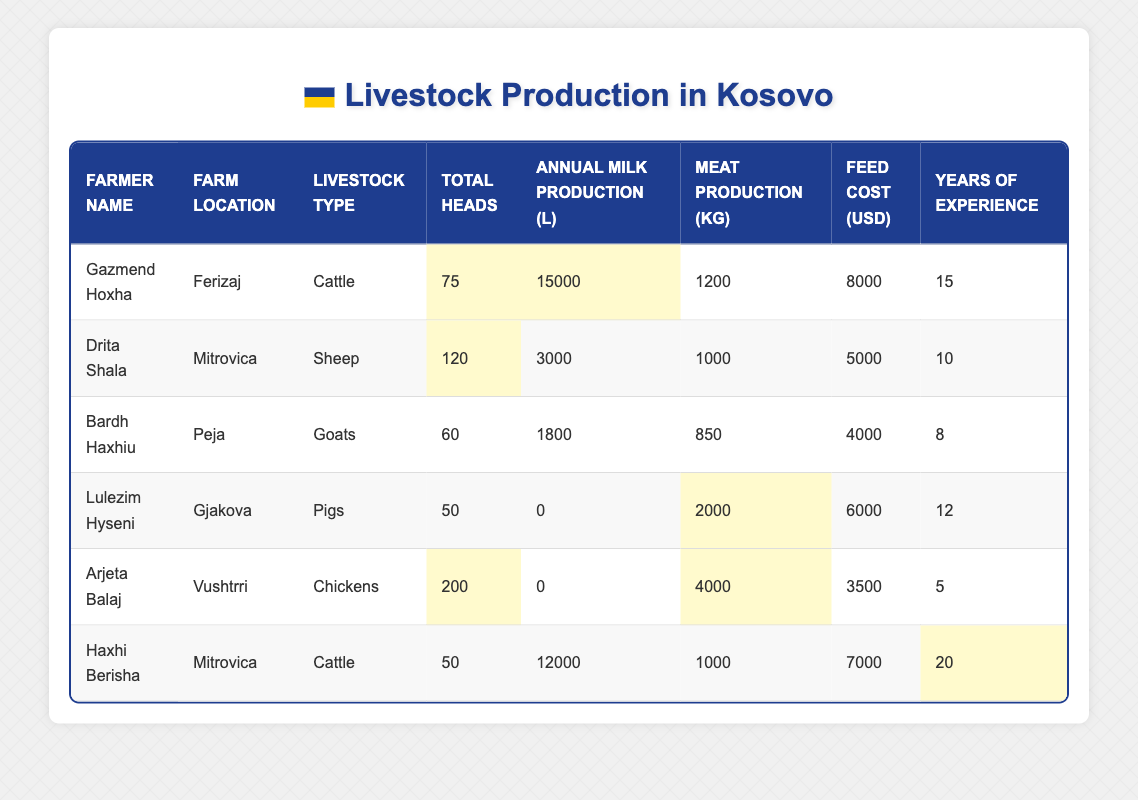What is the total number of livestock heads managed by Drita Shala? According to the table, Drita Shala manages 120 heads of sheep on her farm.
Answer: 120 Which farmer has the highest annual milk production? Gazmend Hoxha has the highest annual milk production at 15,000 liters, compared to others in the table.
Answer: Gazmend Hoxha What is the total meat production in kilograms by all farmers combined? To calculate total meat production, we sum the meat produced by all farmers: 1200 + 1000 + 850 + 2000 + 4000 + 1000 = 10,050 kg.
Answer: 10,050 kg Which farmer has the most years of experience? Haxhi Berisha has the highest experience, with 20 years listed in the table.
Answer: Haxhi Berisha What is the average annual milk production across all farmers? To find the average, we sum the annual milk production: 15000 + 3000 + 1800 + 0 + 0 + 12000 = 19800 liters. There are 6 farmers, so the average is 19800 / 6 = 3300 liters.
Answer: 3,300 liters Is it true that Lulezim Hyseni produces milk? From the table, Lulezim Hyseni has an annual milk production of 0 liters, indicating he does not produce milk. Therefore, the statement is false.
Answer: No How many livestock heads does Arjeta Balaj have compared to Gazmend Hoxha? Arjeta Balaj has 200 heads of chickens, while Gazmend Hoxha has 75 heads of cattle. The difference is 200 - 75 = 125 heads.
Answer: 125 heads more What is the average feed cost per farmer? The total feed costs are: 8000 + 5000 + 4000 + 6000 + 3500 + 7000 = 33000 USD. Dividing this by the 6 farmers gives 33000 / 6 = 5500 USD as the average feed cost.
Answer: 5,500 USD Who among the farmers has the least feed cost? Arjeta Balaj has the least feed cost of 3500 USD, which is lower than that of all other farmers.
Answer: Arjeta Balaj What is the total number of livestock heads for farmers located in Mitrovica? There are two farmers in Mitrovica: Drita Shala with 120 heads and Haxhi Berisha with 50 heads. Their total is 120 + 50 = 170 heads.
Answer: 170 heads 